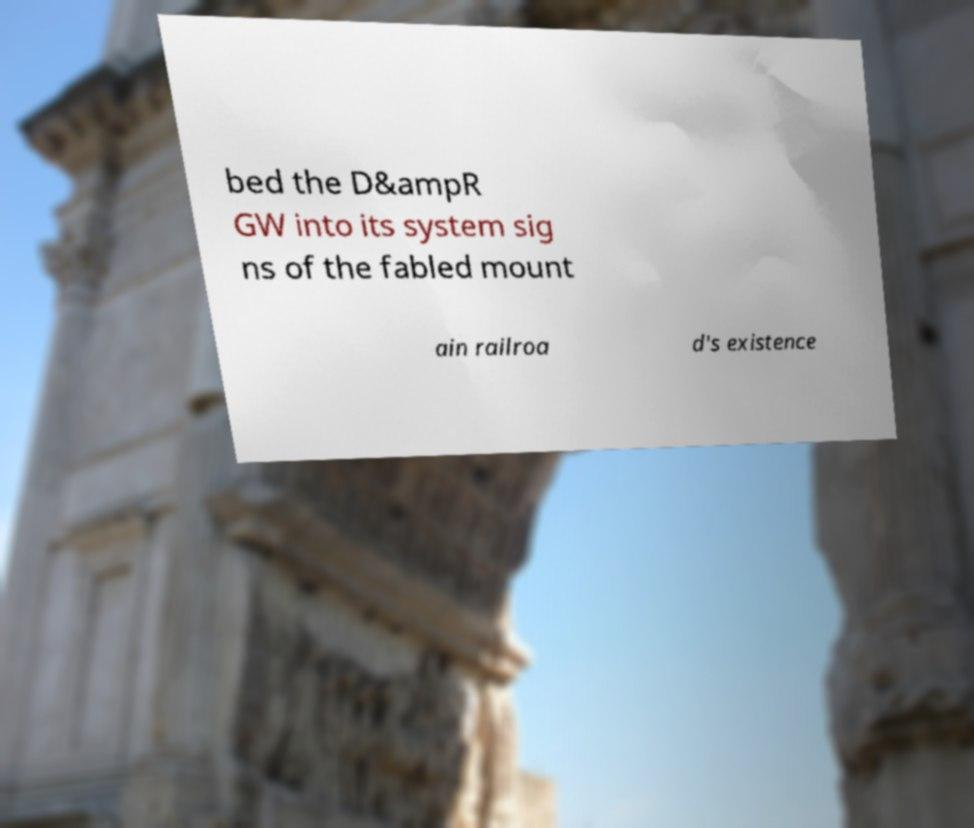What messages or text are displayed in this image? I need them in a readable, typed format. bed the D&ampR GW into its system sig ns of the fabled mount ain railroa d's existence 